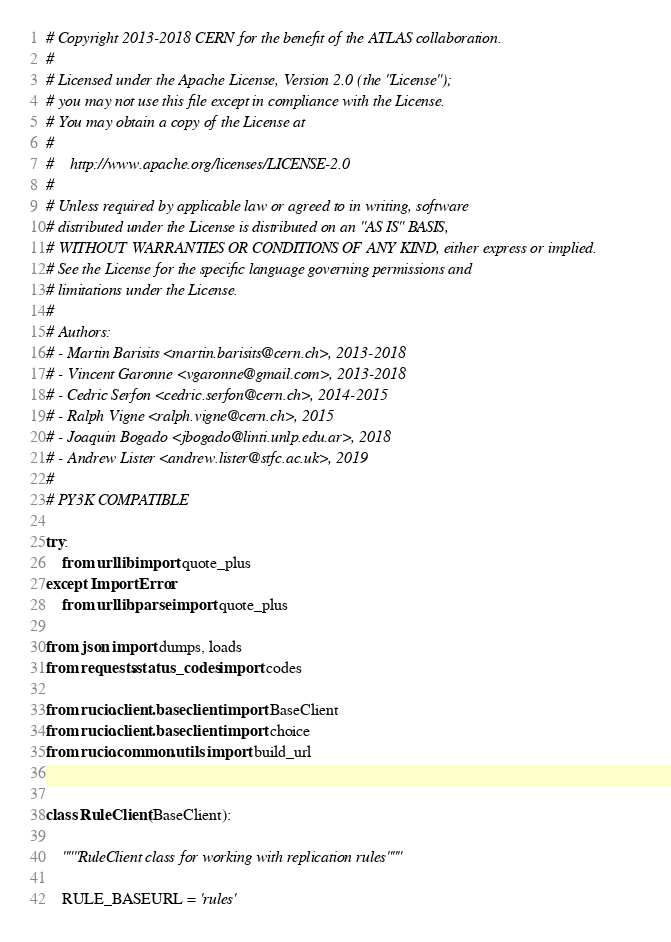<code> <loc_0><loc_0><loc_500><loc_500><_Python_># Copyright 2013-2018 CERN for the benefit of the ATLAS collaboration.
#
# Licensed under the Apache License, Version 2.0 (the "License");
# you may not use this file except in compliance with the License.
# You may obtain a copy of the License at
#
#    http://www.apache.org/licenses/LICENSE-2.0
#
# Unless required by applicable law or agreed to in writing, software
# distributed under the License is distributed on an "AS IS" BASIS,
# WITHOUT WARRANTIES OR CONDITIONS OF ANY KIND, either express or implied.
# See the License for the specific language governing permissions and
# limitations under the License.
#
# Authors:
# - Martin Barisits <martin.barisits@cern.ch>, 2013-2018
# - Vincent Garonne <vgaronne@gmail.com>, 2013-2018
# - Cedric Serfon <cedric.serfon@cern.ch>, 2014-2015
# - Ralph Vigne <ralph.vigne@cern.ch>, 2015
# - Joaquin Bogado <jbogado@linti.unlp.edu.ar>, 2018
# - Andrew Lister <andrew.lister@stfc.ac.uk>, 2019
#
# PY3K COMPATIBLE

try:
    from urllib import quote_plus
except ImportError:
    from urllib.parse import quote_plus

from json import dumps, loads
from requests.status_codes import codes

from rucio.client.baseclient import BaseClient
from rucio.client.baseclient import choice
from rucio.common.utils import build_url


class RuleClient(BaseClient):

    """RuleClient class for working with replication rules"""

    RULE_BASEURL = 'rules'
</code> 